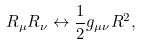<formula> <loc_0><loc_0><loc_500><loc_500>R _ { \mu } R _ { \nu } \leftrightarrow \frac { 1 } { 2 } g _ { \mu \nu } R ^ { 2 } ,</formula> 